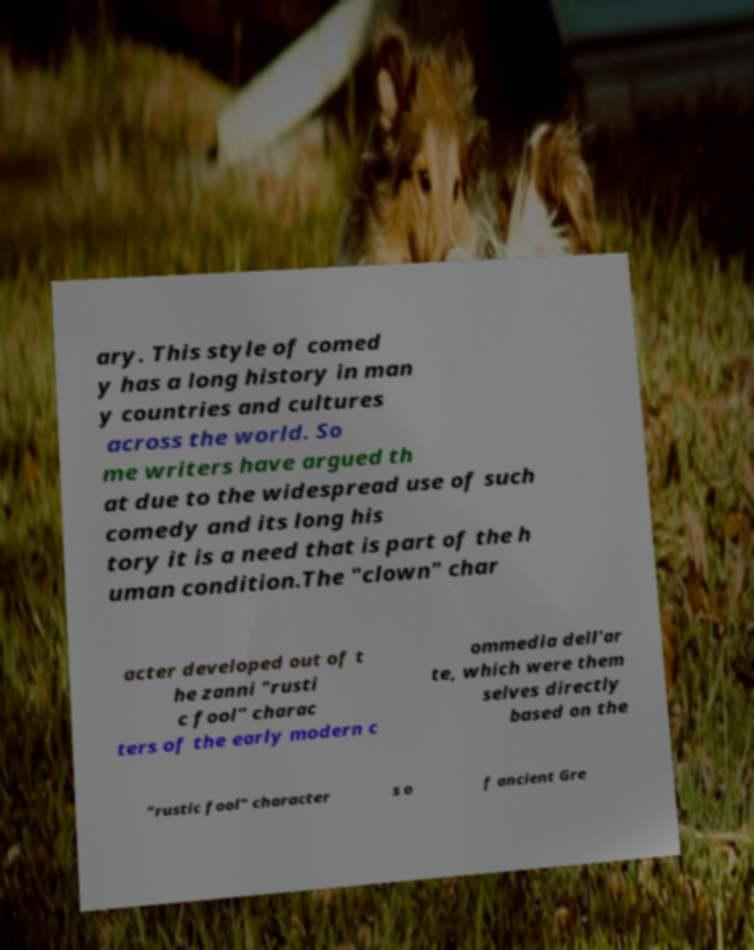There's text embedded in this image that I need extracted. Can you transcribe it verbatim? ary. This style of comed y has a long history in man y countries and cultures across the world. So me writers have argued th at due to the widespread use of such comedy and its long his tory it is a need that is part of the h uman condition.The "clown" char acter developed out of t he zanni "rusti c fool" charac ters of the early modern c ommedia dell'ar te, which were them selves directly based on the "rustic fool" character s o f ancient Gre 